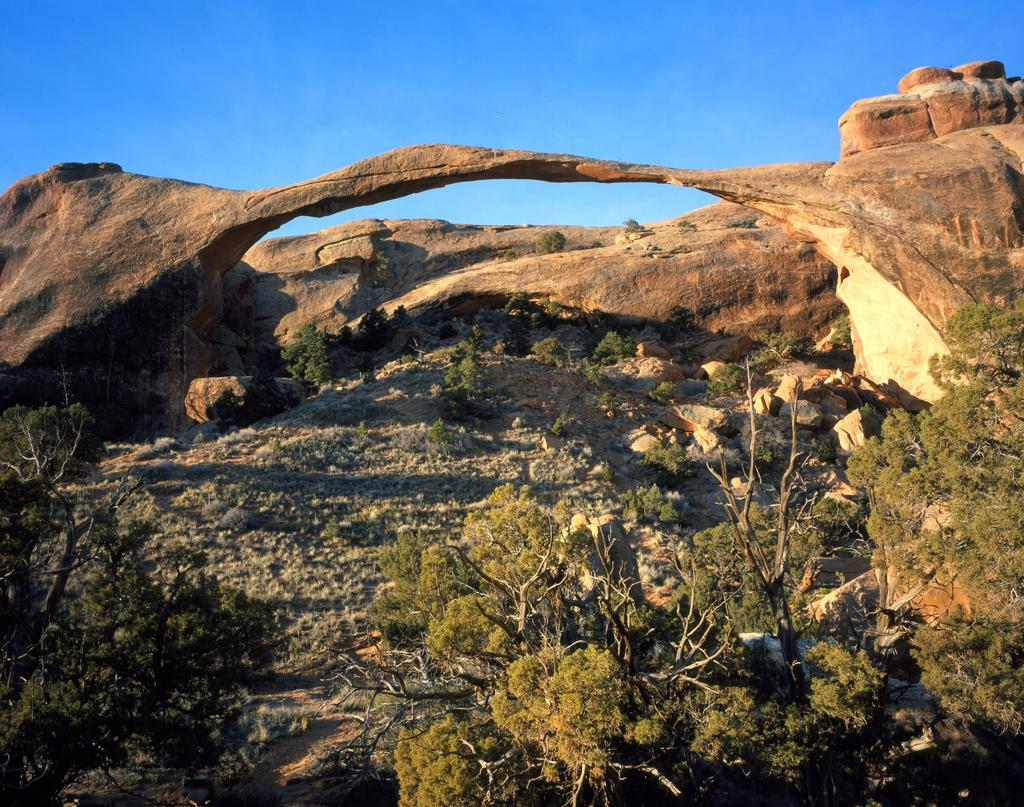What type of vegetation can be seen in the image? There are trees in the image. What type of structure is present in the image? There is an arch in the image. How many books are stacked on the hen in the image? There are no books or hens present in the image; it only features trees and an arch. 